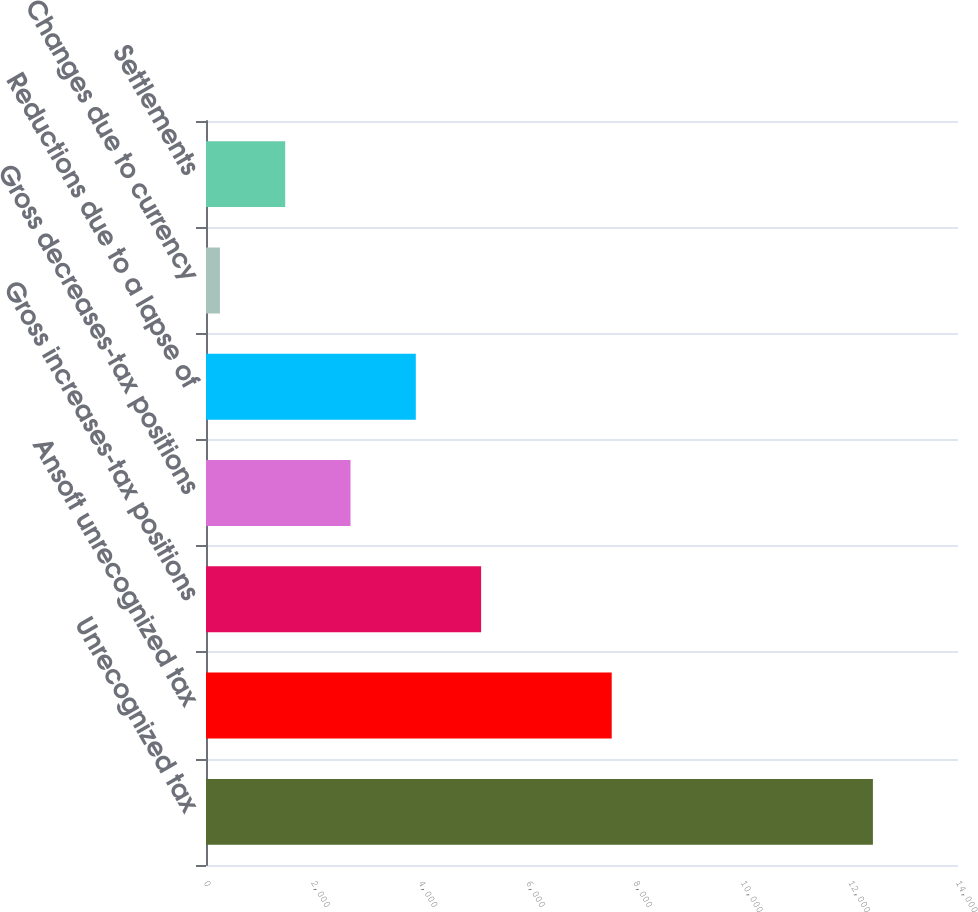Convert chart to OTSL. <chart><loc_0><loc_0><loc_500><loc_500><bar_chart><fcel>Unrecognized tax<fcel>Ansoft unrecognized tax<fcel>Gross increases-tax positions<fcel>Gross decreases-tax positions<fcel>Reductions due to a lapse of<fcel>Changes due to currency<fcel>Settlements<nl><fcel>12416<fcel>7553.2<fcel>5121.8<fcel>2690.4<fcel>3906.1<fcel>259<fcel>1474.7<nl></chart> 